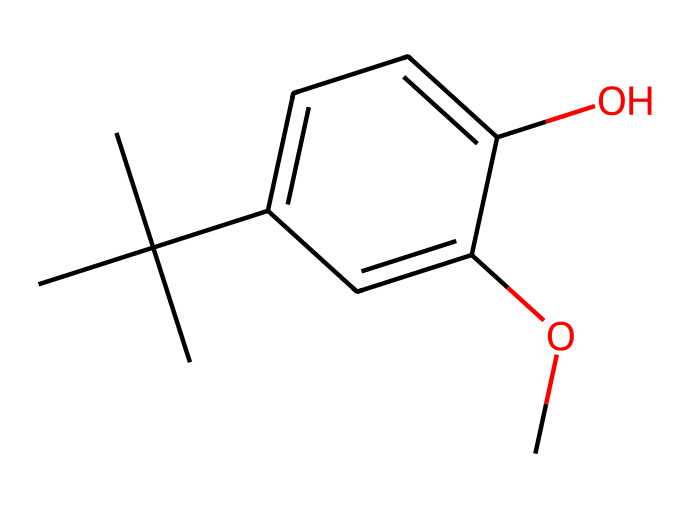What is the molecular formula of BHA? Analyzing the structure, we count the number of carbon (C), hydrogen (H), and oxygen (O) atoms. There are 11 carbon atoms, 14 hydrogen atoms, and 2 oxygen atoms. Thus, the molecular formula is C11H14O2.
Answer: C11H14O2 How many hydroxyl groups are present in BHA? By observing the structure, we can identify the hydroxyl group (-OH) attached to the benzene ring. There is only one such group in this chemical.
Answer: 1 What type of compound is BHA classified as? The presence of aromatic rings and functional groups suggests that BHA is classified as a phenolic compound due to the hydroxyl group attached to the aromatic system.
Answer: phenolic How does BHA function as a preservative? BHA prevents oxidative spoilage by interacting with free radicals due to its phenolic structure, which allows it to stabilize and protect other components in food and packaging materials from deteriorating.
Answer: antioxidant What is the total number of rings in the chemical structure of BHA? The chemical structure contains one aromatic ring as evidenced by the presence of the cyclic arrangement of carbon atoms and alternating double bonds.
Answer: 1 What property of BHA contributes to its effectiveness as a preservative? The electron-donating ability of the hydroxyl group in the aromatic framework allows BHA to stabilize free radicals, making it effective in slowing down oxidation processes that spoil food.
Answer: antioxidant capacity 